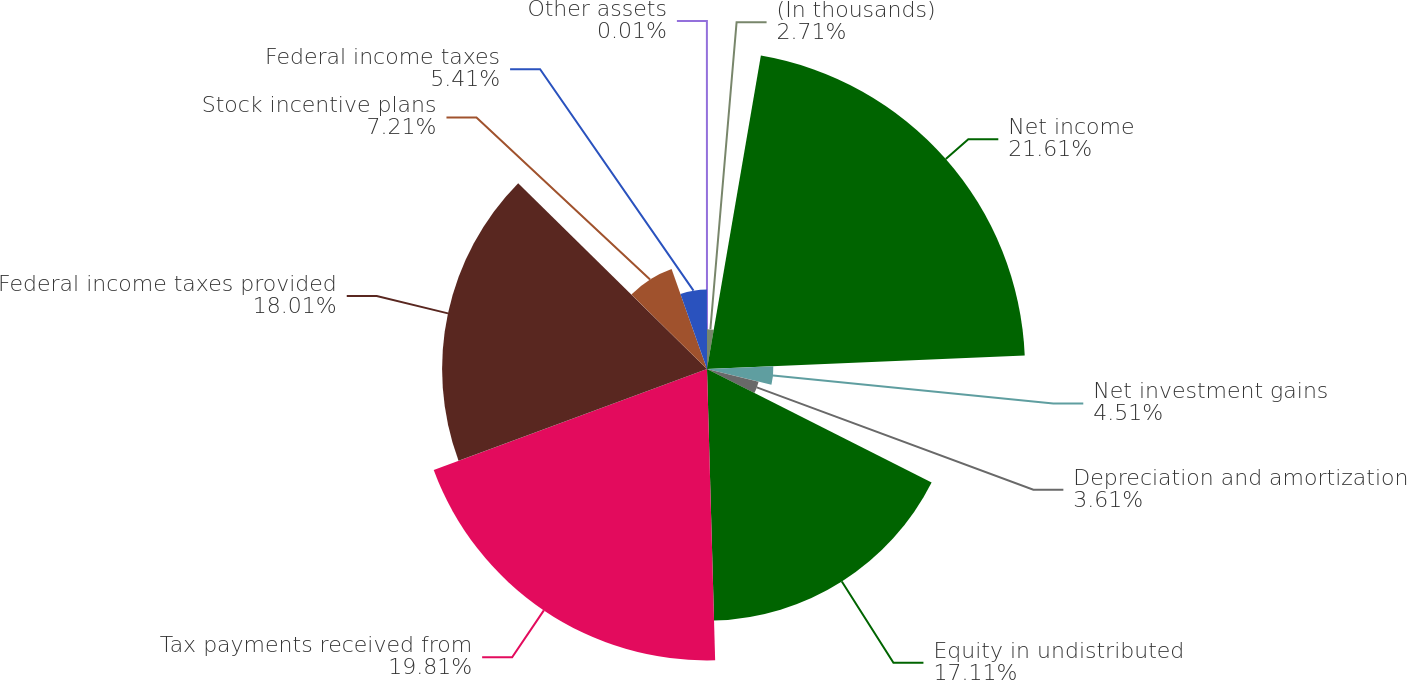<chart> <loc_0><loc_0><loc_500><loc_500><pie_chart><fcel>(In thousands)<fcel>Net income<fcel>Net investment gains<fcel>Depreciation and amortization<fcel>Equity in undistributed<fcel>Tax payments received from<fcel>Federal income taxes provided<fcel>Stock incentive plans<fcel>Federal income taxes<fcel>Other assets<nl><fcel>2.71%<fcel>21.62%<fcel>4.51%<fcel>3.61%<fcel>17.11%<fcel>19.81%<fcel>18.01%<fcel>7.21%<fcel>5.41%<fcel>0.01%<nl></chart> 